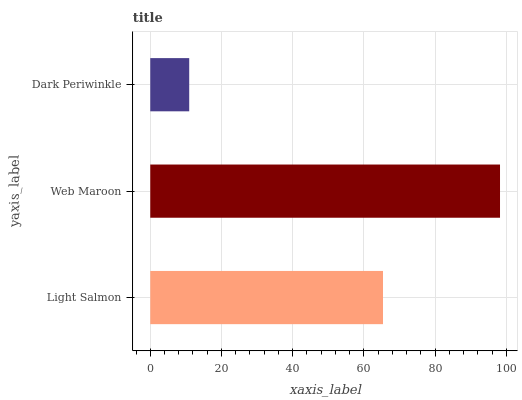Is Dark Periwinkle the minimum?
Answer yes or no. Yes. Is Web Maroon the maximum?
Answer yes or no. Yes. Is Web Maroon the minimum?
Answer yes or no. No. Is Dark Periwinkle the maximum?
Answer yes or no. No. Is Web Maroon greater than Dark Periwinkle?
Answer yes or no. Yes. Is Dark Periwinkle less than Web Maroon?
Answer yes or no. Yes. Is Dark Periwinkle greater than Web Maroon?
Answer yes or no. No. Is Web Maroon less than Dark Periwinkle?
Answer yes or no. No. Is Light Salmon the high median?
Answer yes or no. Yes. Is Light Salmon the low median?
Answer yes or no. Yes. Is Web Maroon the high median?
Answer yes or no. No. Is Dark Periwinkle the low median?
Answer yes or no. No. 